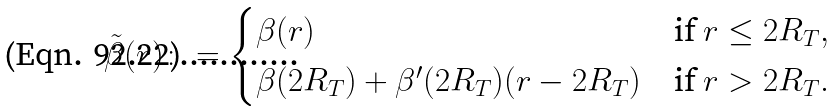<formula> <loc_0><loc_0><loc_500><loc_500>\tilde { \beta } ( r ) \colon = \begin{cases} \beta ( r ) & \text {if } r \leq 2 R _ { T } , \\ \beta ( 2 R _ { T } ) + \beta ^ { \prime } ( 2 R _ { T } ) ( r - 2 R _ { T } ) & \text {if } r > 2 R _ { T } . \end{cases}</formula> 